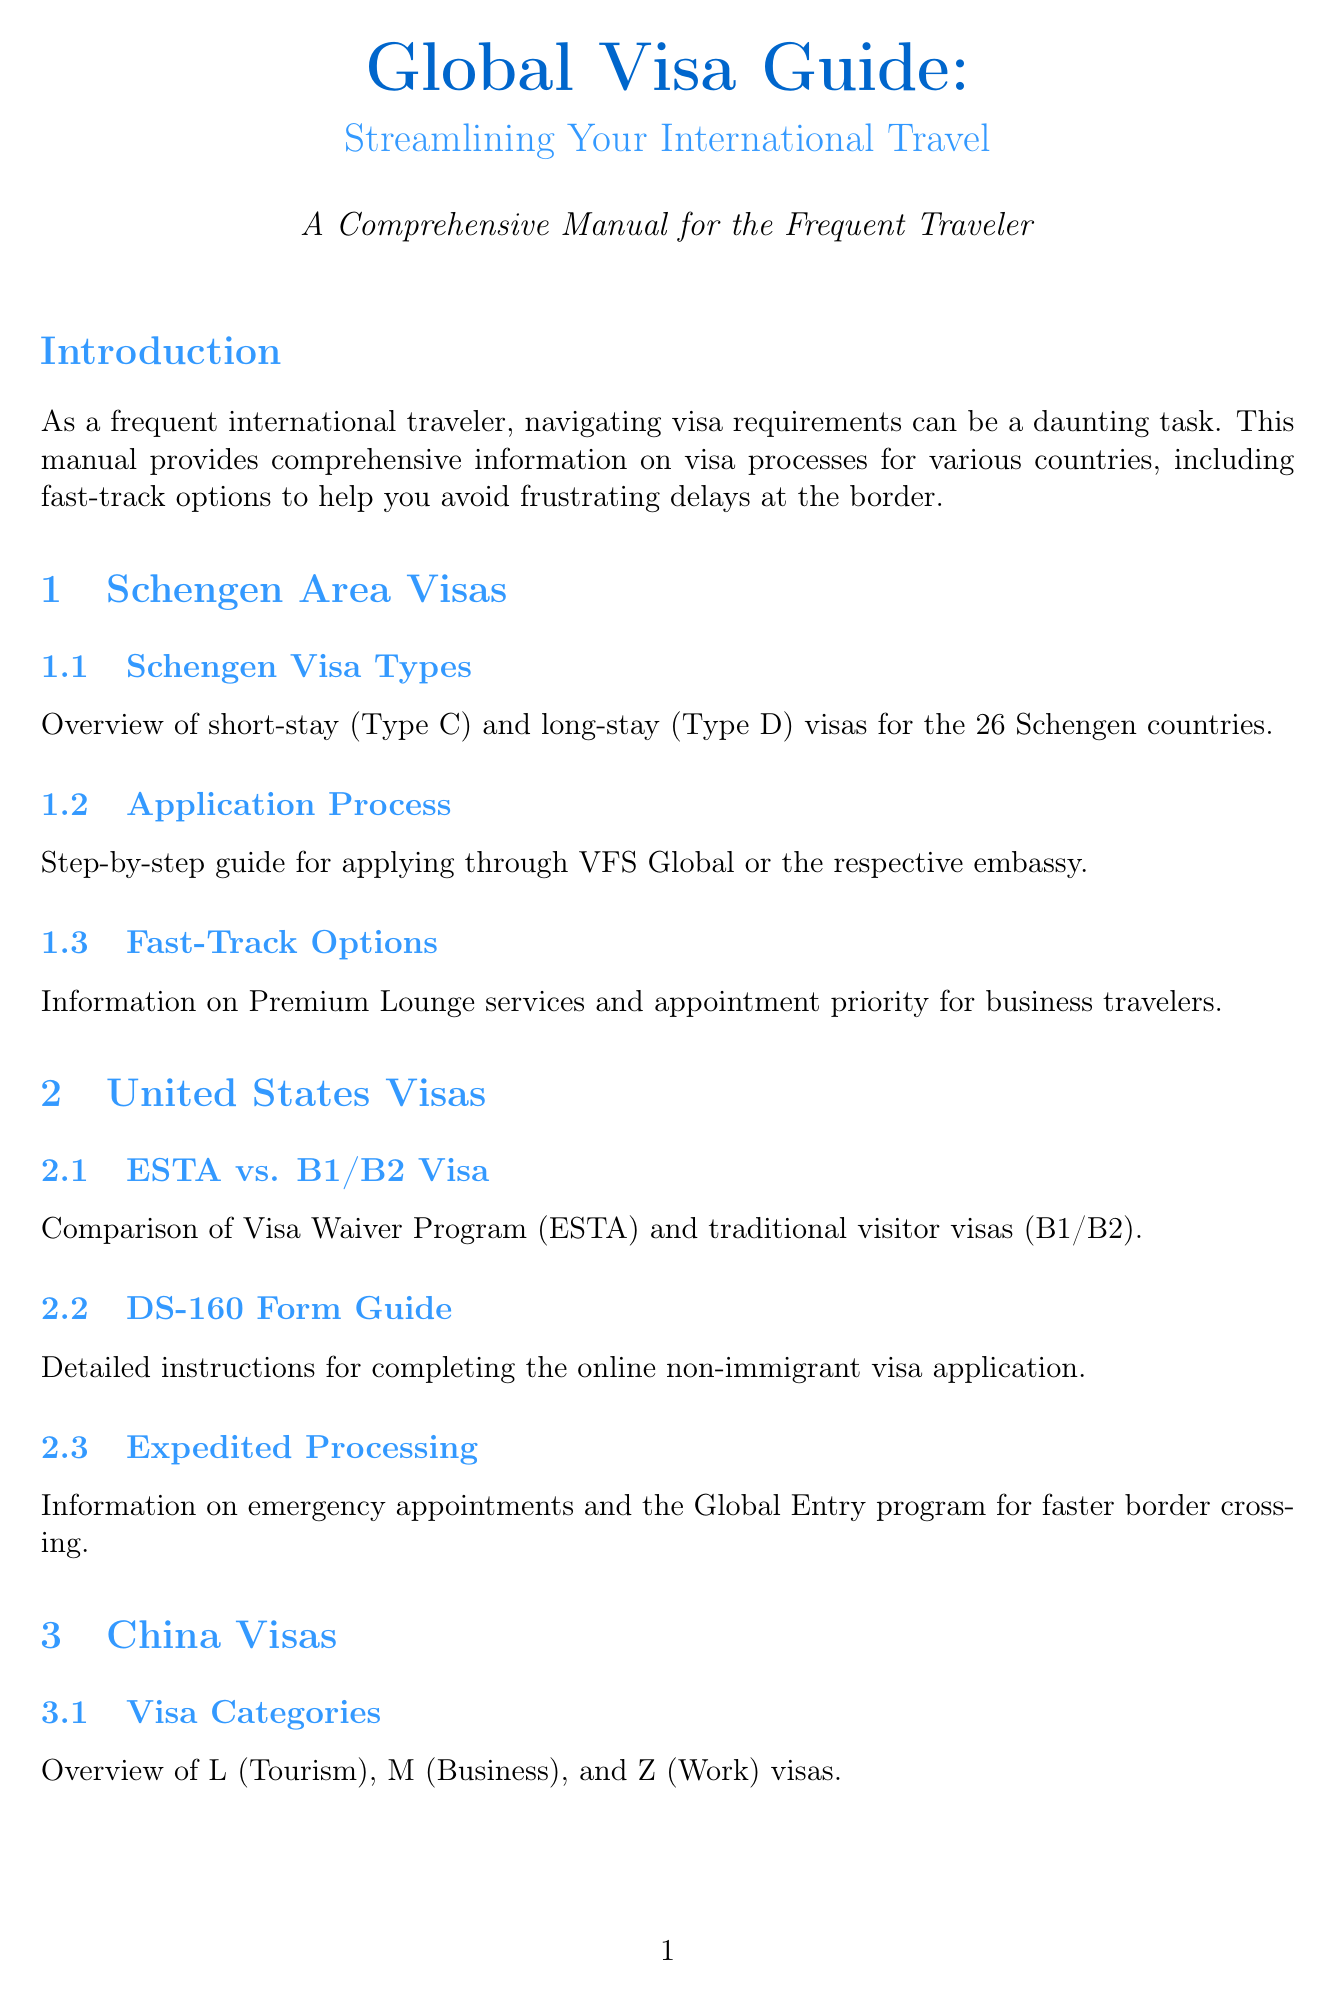What is the title of the manual? The title of the manual is provided in the introduction section.
Answer: Global Visa Guide: Streamlining Your International Travel How many Schengen countries are there? The number of Schengen countries is mentioned in the section about Schengen Visa Types.
Answer: 26 What is the DS-160 form used for? The document explains the purpose of the DS-160 form in the United States Visas chapter.
Answer: Completing the online non-immigrant visa application What expedited processing option is mentioned for India? This option is detailed in the India Visas section, indicating urgency.
Answer: Expedited processing Which service is available for faster border crossing in the United States? The relevant section discusses the programs available for speeding up border crossing.
Answer: Global Entry program What types of visas are covered under China Visas? The variety of visa categories is listed in the visa categories section for China.
Answer: L (Tourism), M (Business), Z (Work) What online platform is recommended for UAE visa applications? The manual discusses the online application system and mentions this specific portal.
Answer: ICA Smart Services portal What type of visa service does Brazil offer for expedited processing? This is mentioned under VIP Visa Service in the Brazil Visas section.
Answer: Premium services offered by specialized visa agencies What is included in the document checklist? This checklist includes details about necessary documents for visa applications.
Answer: Passport, photographs, bank statements, travel itineraries 